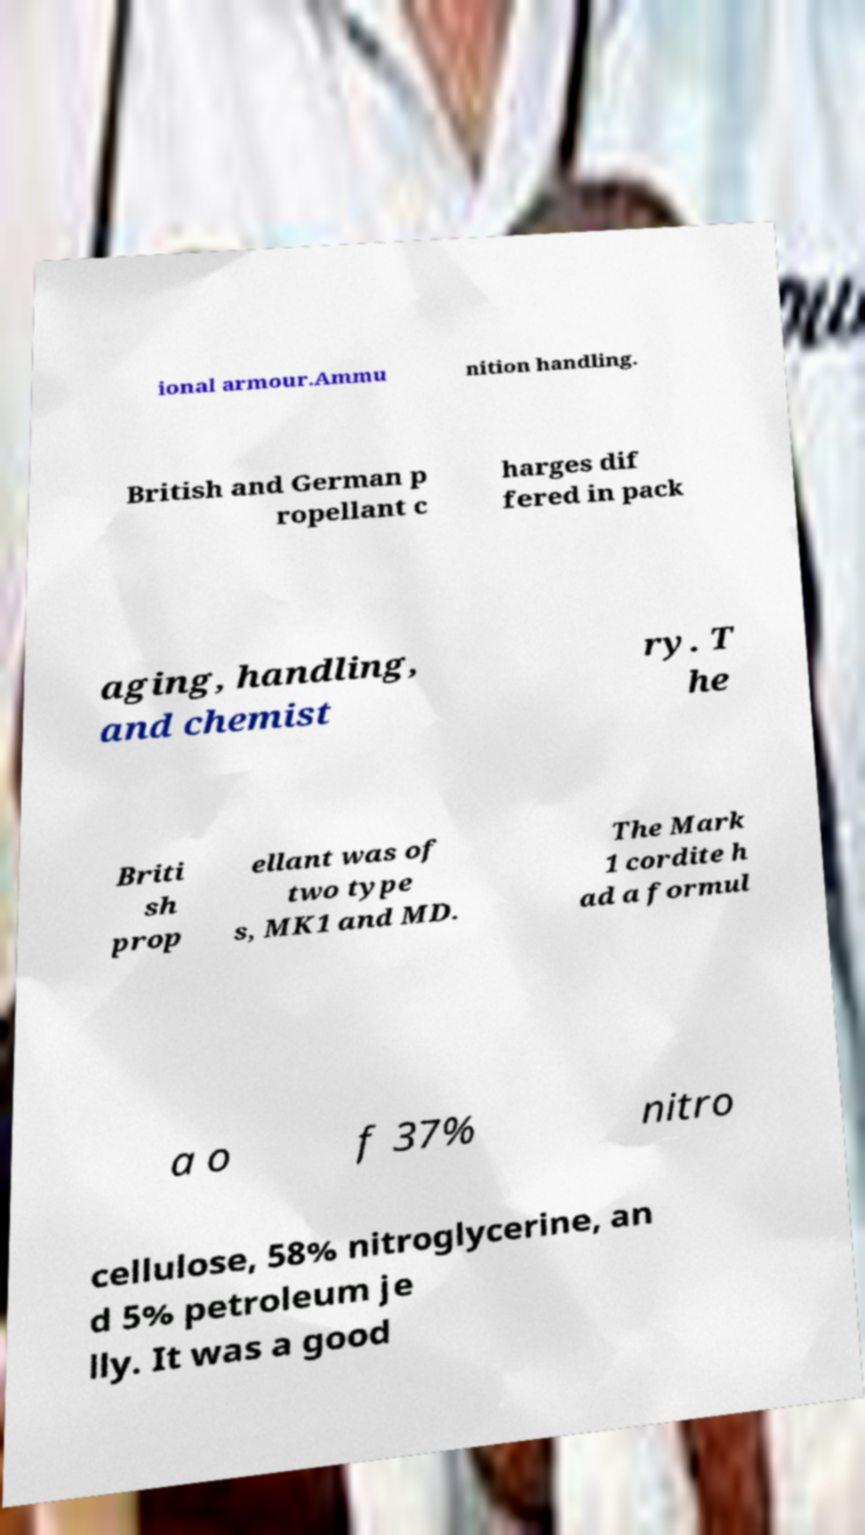Could you extract and type out the text from this image? ional armour.Ammu nition handling. British and German p ropellant c harges dif fered in pack aging, handling, and chemist ry. T he Briti sh prop ellant was of two type s, MK1 and MD. The Mark 1 cordite h ad a formul a o f 37% nitro cellulose, 58% nitroglycerine, an d 5% petroleum je lly. It was a good 